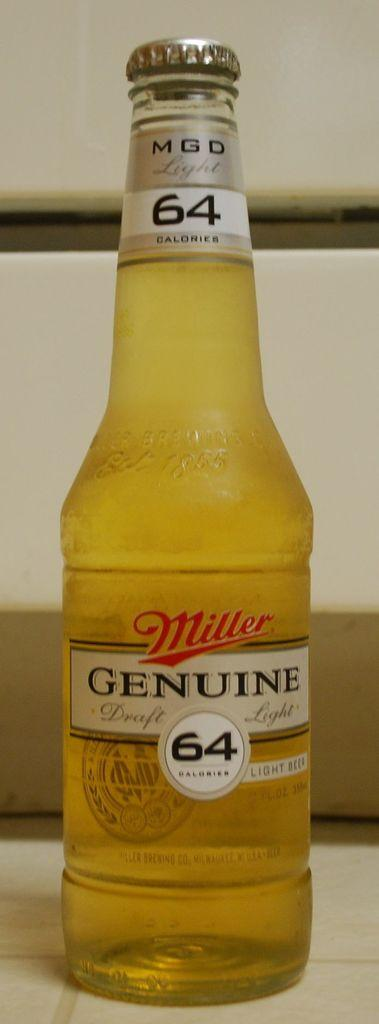<image>
Relay a brief, clear account of the picture shown. Miller Genuine bottle that shows 64 calories in the front. 